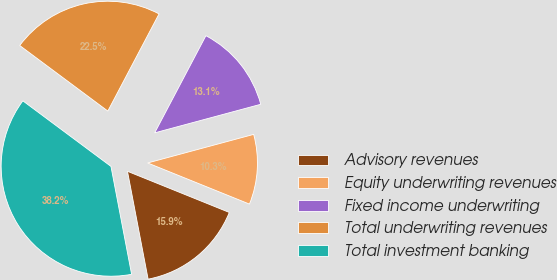Convert chart to OTSL. <chart><loc_0><loc_0><loc_500><loc_500><pie_chart><fcel>Advisory revenues<fcel>Equity underwriting revenues<fcel>Fixed income underwriting<fcel>Total underwriting revenues<fcel>Total investment banking<nl><fcel>15.88%<fcel>10.3%<fcel>13.09%<fcel>22.54%<fcel>38.19%<nl></chart> 